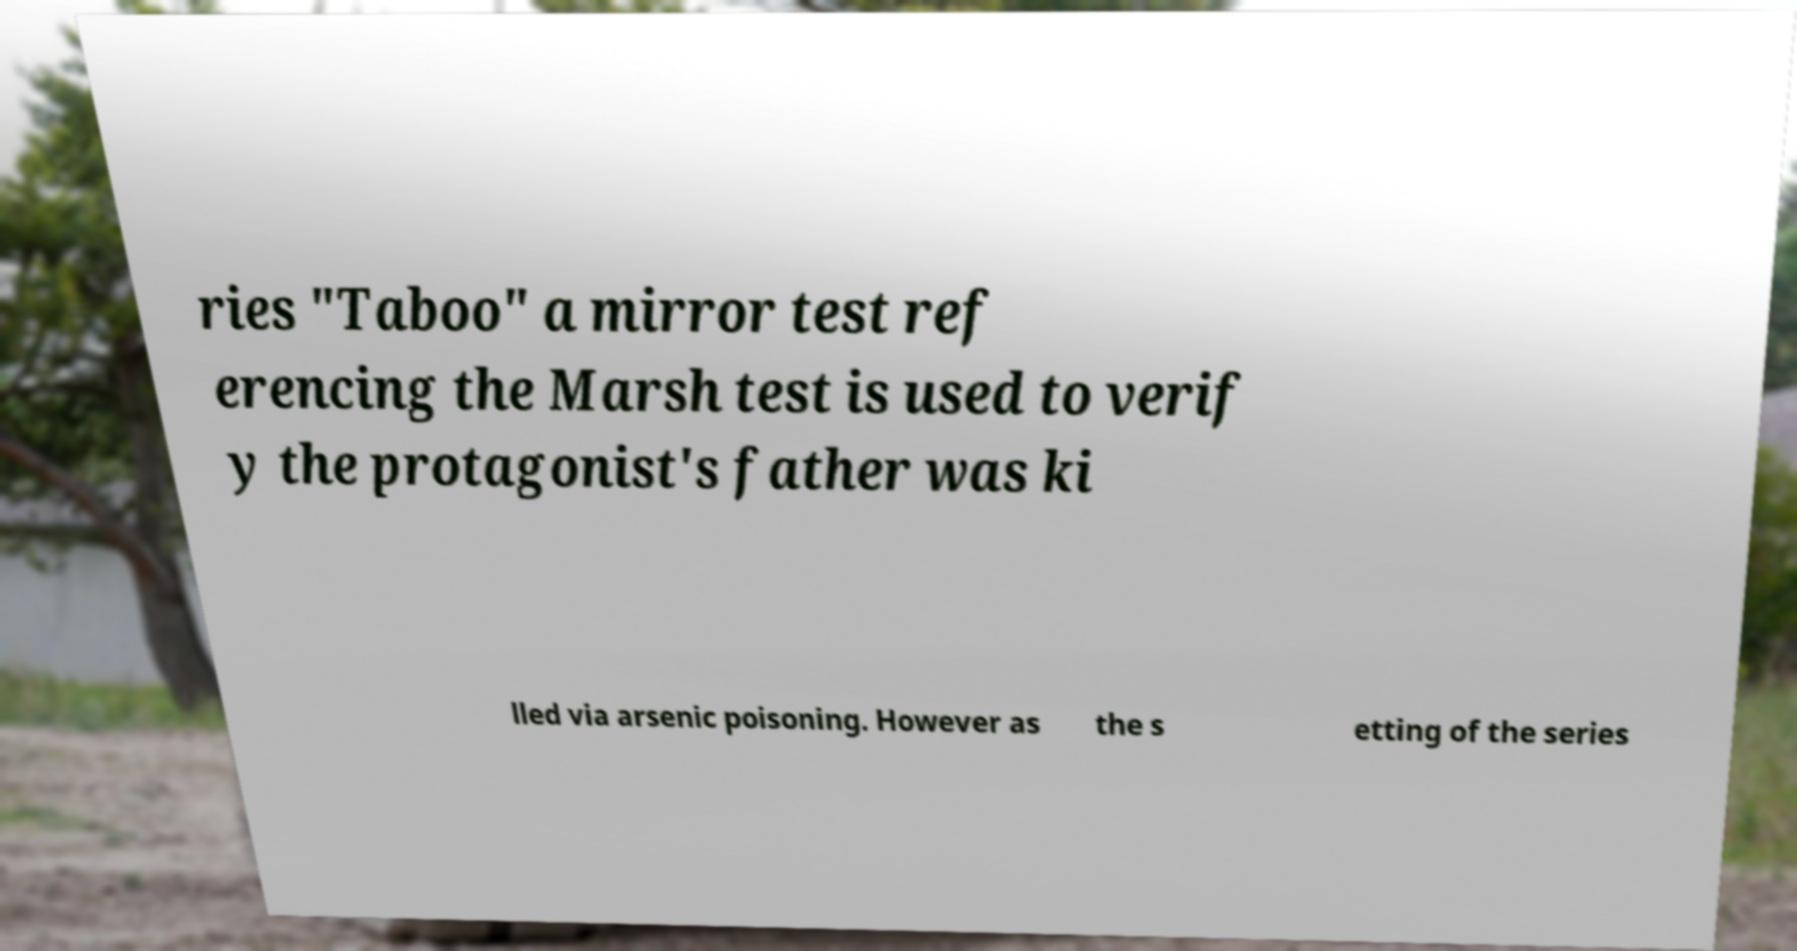Could you extract and type out the text from this image? ries "Taboo" a mirror test ref erencing the Marsh test is used to verif y the protagonist's father was ki lled via arsenic poisoning. However as the s etting of the series 